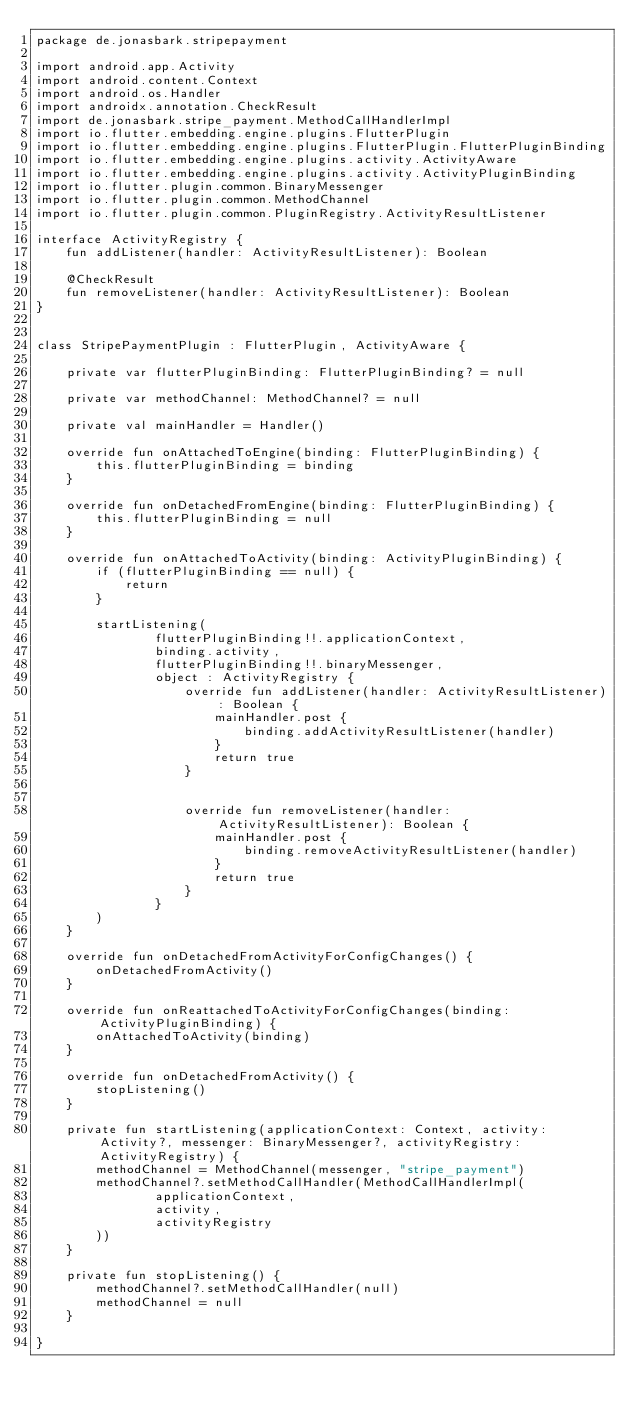<code> <loc_0><loc_0><loc_500><loc_500><_Kotlin_>package de.jonasbark.stripepayment

import android.app.Activity
import android.content.Context
import android.os.Handler
import androidx.annotation.CheckResult
import de.jonasbark.stripe_payment.MethodCallHandlerImpl
import io.flutter.embedding.engine.plugins.FlutterPlugin
import io.flutter.embedding.engine.plugins.FlutterPlugin.FlutterPluginBinding
import io.flutter.embedding.engine.plugins.activity.ActivityAware
import io.flutter.embedding.engine.plugins.activity.ActivityPluginBinding
import io.flutter.plugin.common.BinaryMessenger
import io.flutter.plugin.common.MethodChannel
import io.flutter.plugin.common.PluginRegistry.ActivityResultListener

interface ActivityRegistry {
    fun addListener(handler: ActivityResultListener): Boolean

    @CheckResult
    fun removeListener(handler: ActivityResultListener): Boolean
}


class StripePaymentPlugin : FlutterPlugin, ActivityAware {

    private var flutterPluginBinding: FlutterPluginBinding? = null

    private var methodChannel: MethodChannel? = null

    private val mainHandler = Handler()

    override fun onAttachedToEngine(binding: FlutterPluginBinding) {
        this.flutterPluginBinding = binding
    }

    override fun onDetachedFromEngine(binding: FlutterPluginBinding) {
        this.flutterPluginBinding = null
    }

    override fun onAttachedToActivity(binding: ActivityPluginBinding) {
        if (flutterPluginBinding == null) {
            return
        }

        startListening(
                flutterPluginBinding!!.applicationContext,
                binding.activity,
                flutterPluginBinding!!.binaryMessenger,
                object : ActivityRegistry {
                    override fun addListener(handler: ActivityResultListener): Boolean {
                        mainHandler.post {
                            binding.addActivityResultListener(handler)
                        }
                        return true
                    }


                    override fun removeListener(handler: ActivityResultListener): Boolean {
                        mainHandler.post {
                            binding.removeActivityResultListener(handler)
                        }
                        return true
                    }
                }
        )
    }

    override fun onDetachedFromActivityForConfigChanges() {
        onDetachedFromActivity()
    }

    override fun onReattachedToActivityForConfigChanges(binding: ActivityPluginBinding) {
        onAttachedToActivity(binding)
    }

    override fun onDetachedFromActivity() {
        stopListening()
    }

    private fun startListening(applicationContext: Context, activity: Activity?, messenger: BinaryMessenger?, activityRegistry: ActivityRegistry) {
        methodChannel = MethodChannel(messenger, "stripe_payment")
        methodChannel?.setMethodCallHandler(MethodCallHandlerImpl(
                applicationContext,
                activity,
                activityRegistry
        ))
    }

    private fun stopListening() {
        methodChannel?.setMethodCallHandler(null)
        methodChannel = null
    }

}
</code> 